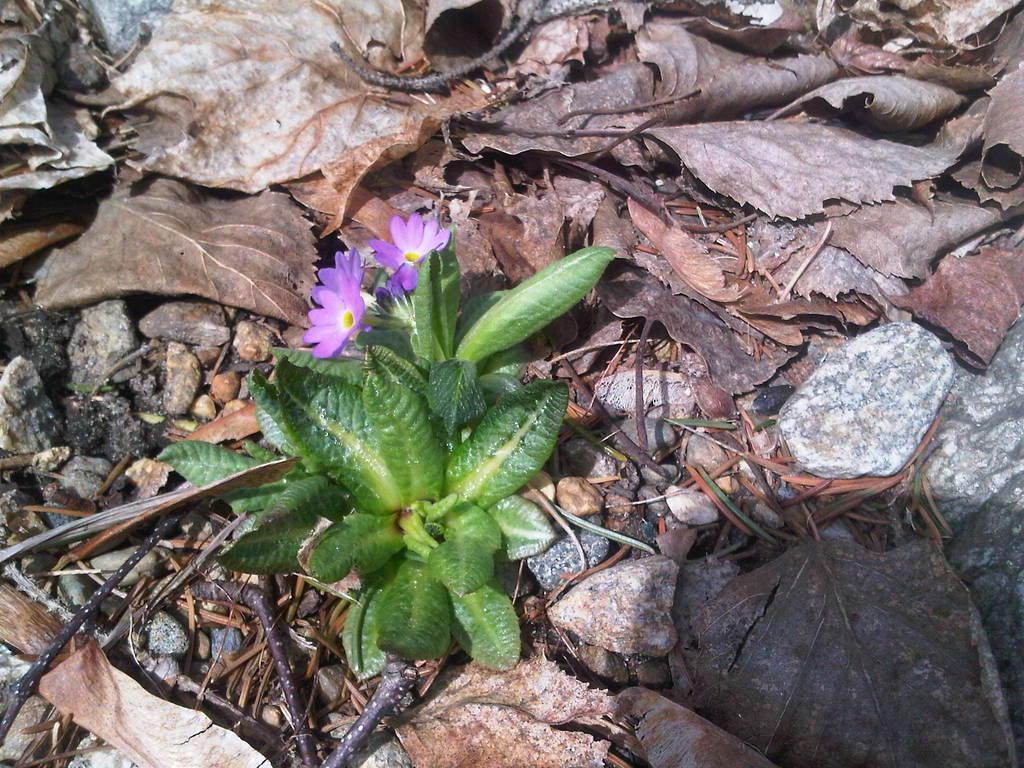How would you summarize this image in a sentence or two? In this image we can see a plant with flowers. In the background, we can see dry leaves and stones. Here we can see the shadow. 